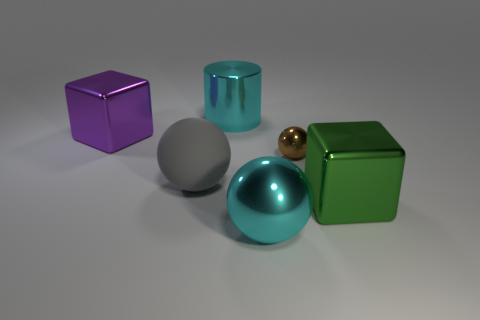How many other objects are there of the same color as the shiny cylinder?
Give a very brief answer. 1. Do the large metallic cylinder and the big metal sphere have the same color?
Offer a very short reply. Yes. There is a large sphere that is the same color as the metallic cylinder; what is its material?
Keep it short and to the point. Metal. The green shiny object has what shape?
Make the answer very short. Cube. What material is the cyan thing that is behind the tiny brown object?
Make the answer very short. Metal. Is there a big shiny object that has the same color as the large rubber thing?
Make the answer very short. No. There is a purple metallic thing that is the same size as the cyan metallic cylinder; what is its shape?
Make the answer very short. Cube. What color is the cube right of the cyan ball?
Ensure brevity in your answer.  Green. There is a gray matte object that is left of the tiny brown metallic sphere; is there a cyan metallic ball behind it?
Your answer should be very brief. No. How many objects are cyan balls that are to the right of the big cyan cylinder or purple metal things?
Give a very brief answer. 2. 